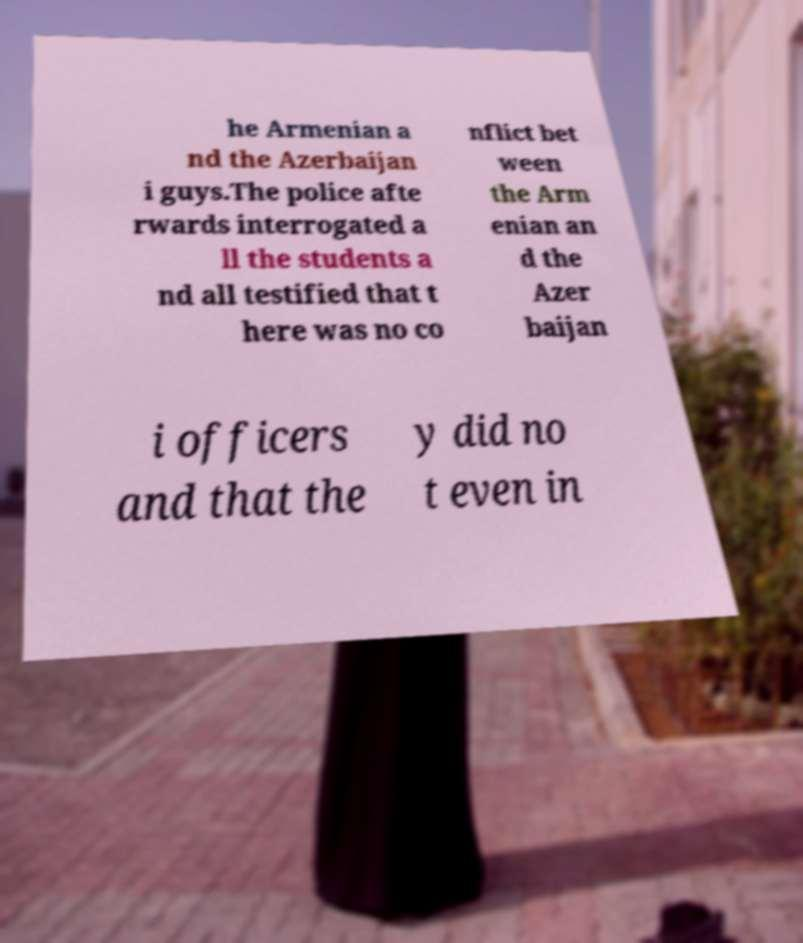Could you extract and type out the text from this image? he Armenian a nd the Azerbaijan i guys.The police afte rwards interrogated a ll the students a nd all testified that t here was no co nflict bet ween the Arm enian an d the Azer baijan i officers and that the y did no t even in 